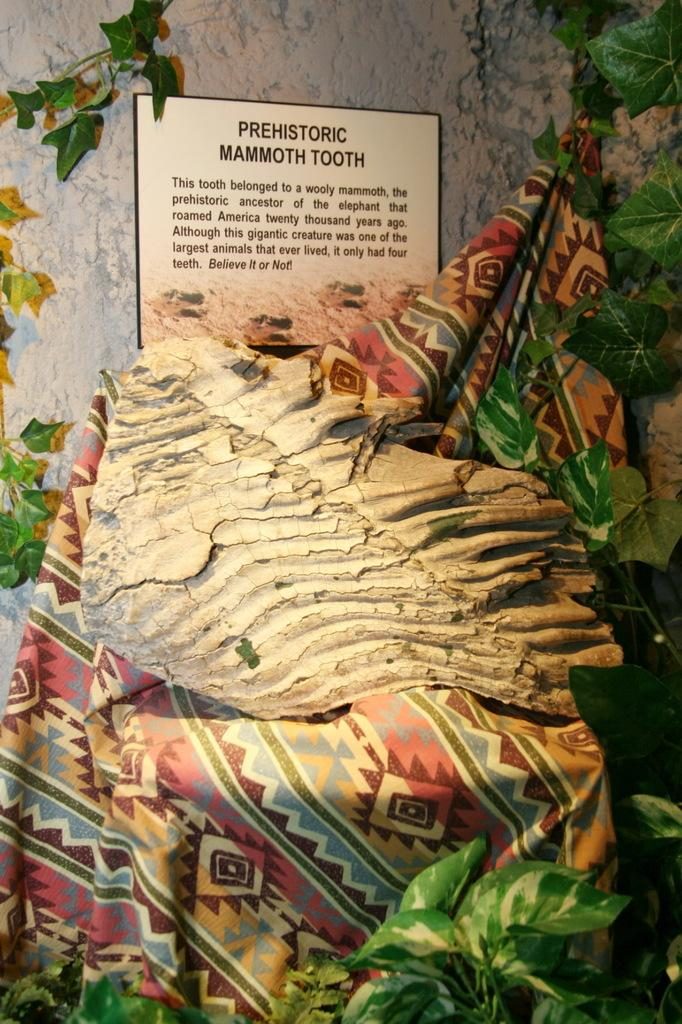Provide a one-sentence caption for the provided image. A museum exhibit that says PREHISTORIC MAMMOTH TOOTH and some more text. 